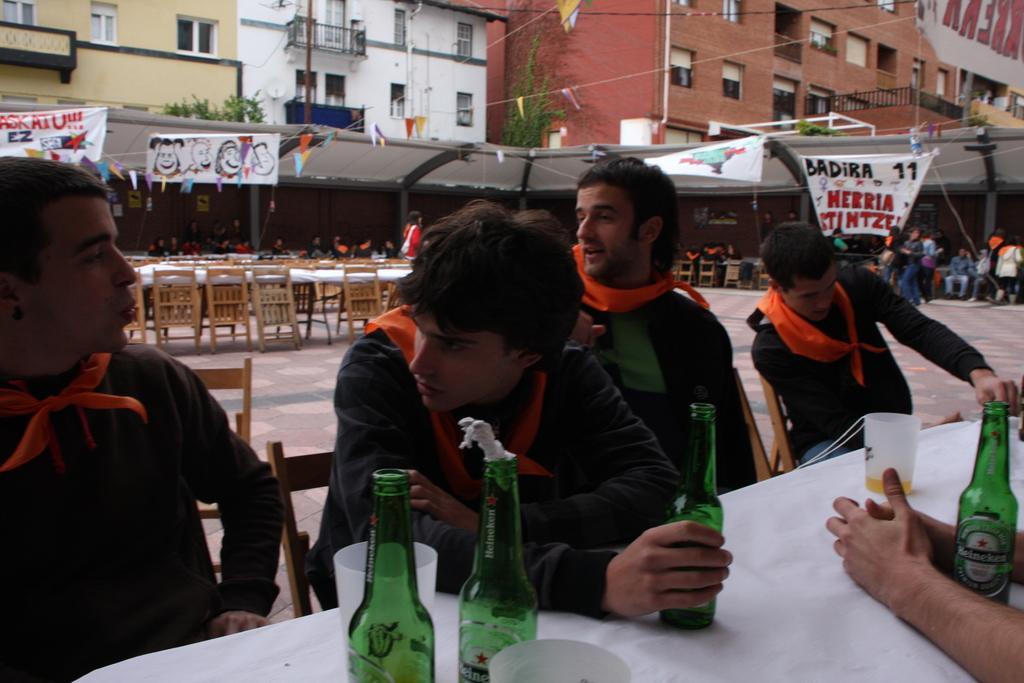Can you describe this image briefly? Here a group of people sitting on the chairs around the table and we have some bottles, glasses on the table. Behind them there are some chairs and tables and also some group of people around them. 